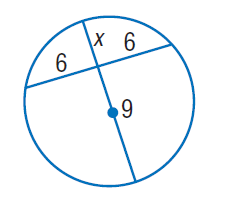Answer the mathemtical geometry problem and directly provide the correct option letter.
Question: Find x. Round to the nearest tenth if necessary. Assume that segments that appear to be tangent are tangent.
Choices: A: 4 B: 6 C: 9 D: 12 A 